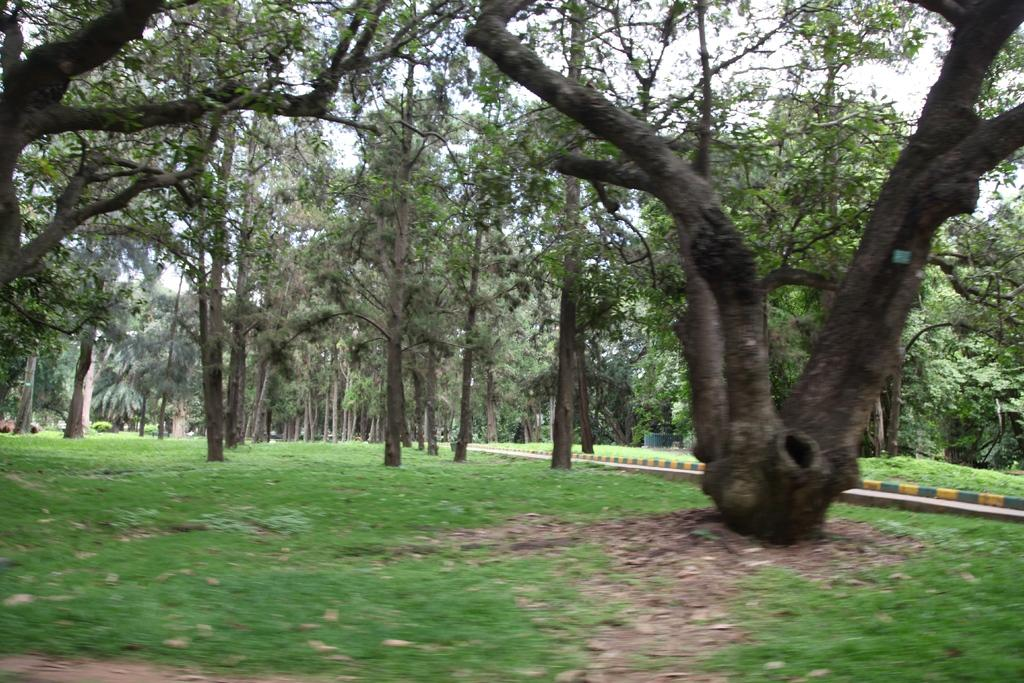What type of vegetation can be seen in the image? There are trees in the image. What else can be seen on the ground in the image? There is grass in the image. What is located on the right side of the image? There is a road on the right side of the image. What type of insurance policy is being discussed by the group of people in the image? There is no group of people present in the image, nor is there any discussion about insurance. 